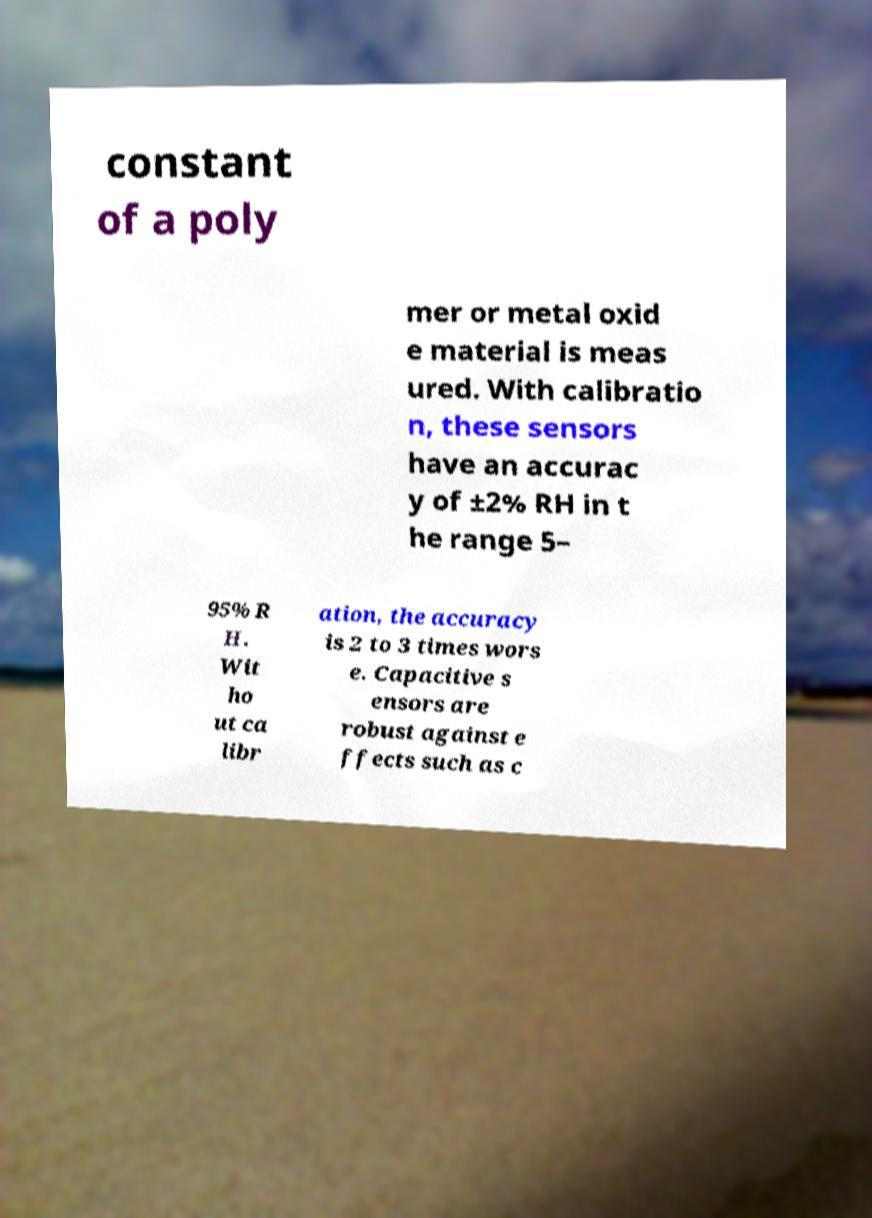Can you accurately transcribe the text from the provided image for me? constant of a poly mer or metal oxid e material is meas ured. With calibratio n, these sensors have an accurac y of ±2% RH in t he range 5– 95% R H. Wit ho ut ca libr ation, the accuracy is 2 to 3 times wors e. Capacitive s ensors are robust against e ffects such as c 